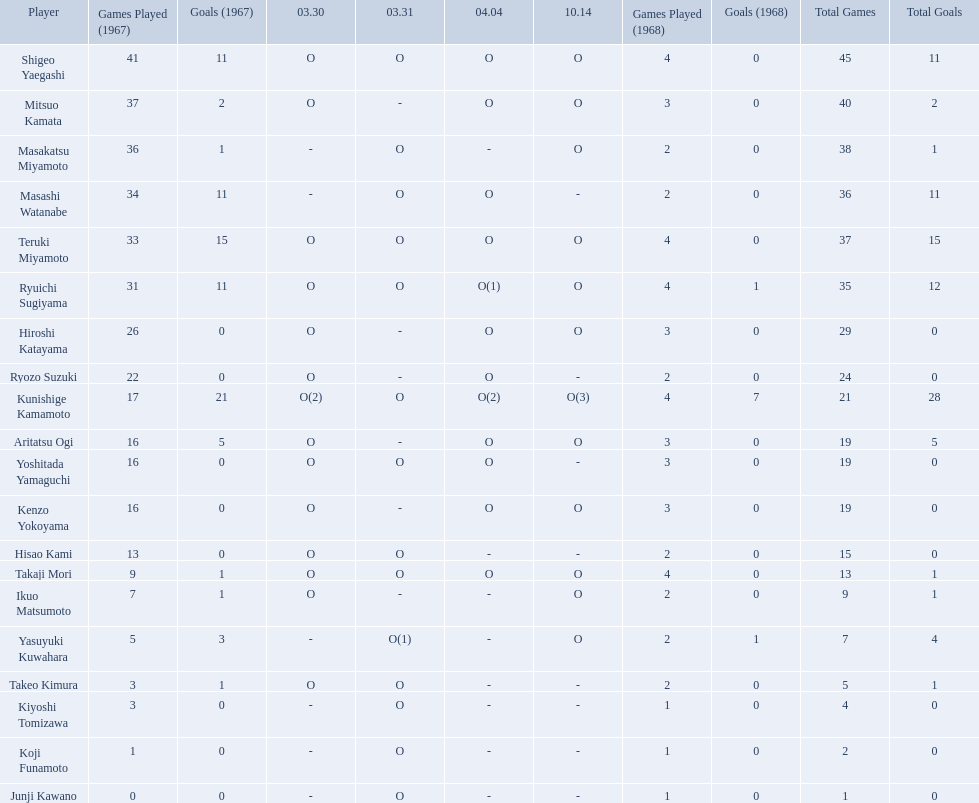How many points did takaji mori have? 13(1). And how many points did junji kawano have? 1(0). To who does the higher of these belong to? Takaji Mori. 